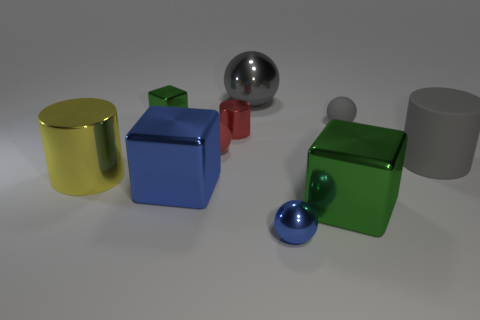How many other objects are there of the same size as the red metal object?
Ensure brevity in your answer.  4. There is a gray thing that is the same size as the blue metallic ball; what is its material?
Make the answer very short. Rubber. What is the color of the sphere on the right side of the big metal object to the right of the metallic sphere in front of the tiny green metal block?
Your answer should be very brief. Gray. There is a blue thing that is on the left side of the small blue ball; is its shape the same as the large gray object right of the big green metal cube?
Make the answer very short. No. How many small matte objects are there?
Provide a short and direct response. 2. What color is the sphere that is the same size as the yellow shiny cylinder?
Ensure brevity in your answer.  Gray. Do the tiny gray thing that is behind the red metallic object and the cylinder that is right of the big green shiny thing have the same material?
Offer a terse response. Yes. What is the size of the matte object that is to the left of the green cube in front of the big gray cylinder?
Your response must be concise. Small. There is a big cylinder left of the tiny red shiny cylinder; what is it made of?
Keep it short and to the point. Metal. What number of things are big shiny things that are behind the small shiny cylinder or green things that are right of the red rubber ball?
Give a very brief answer. 2. 